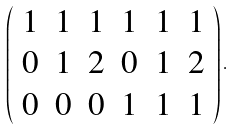<formula> <loc_0><loc_0><loc_500><loc_500>\left ( \begin{array} { l l l l l l } 1 & 1 & 1 & 1 & 1 & 1 \\ 0 & 1 & 2 & 0 & 1 & 2 \\ 0 & 0 & 0 & 1 & 1 & 1 \\ \end{array} \right ) .</formula> 